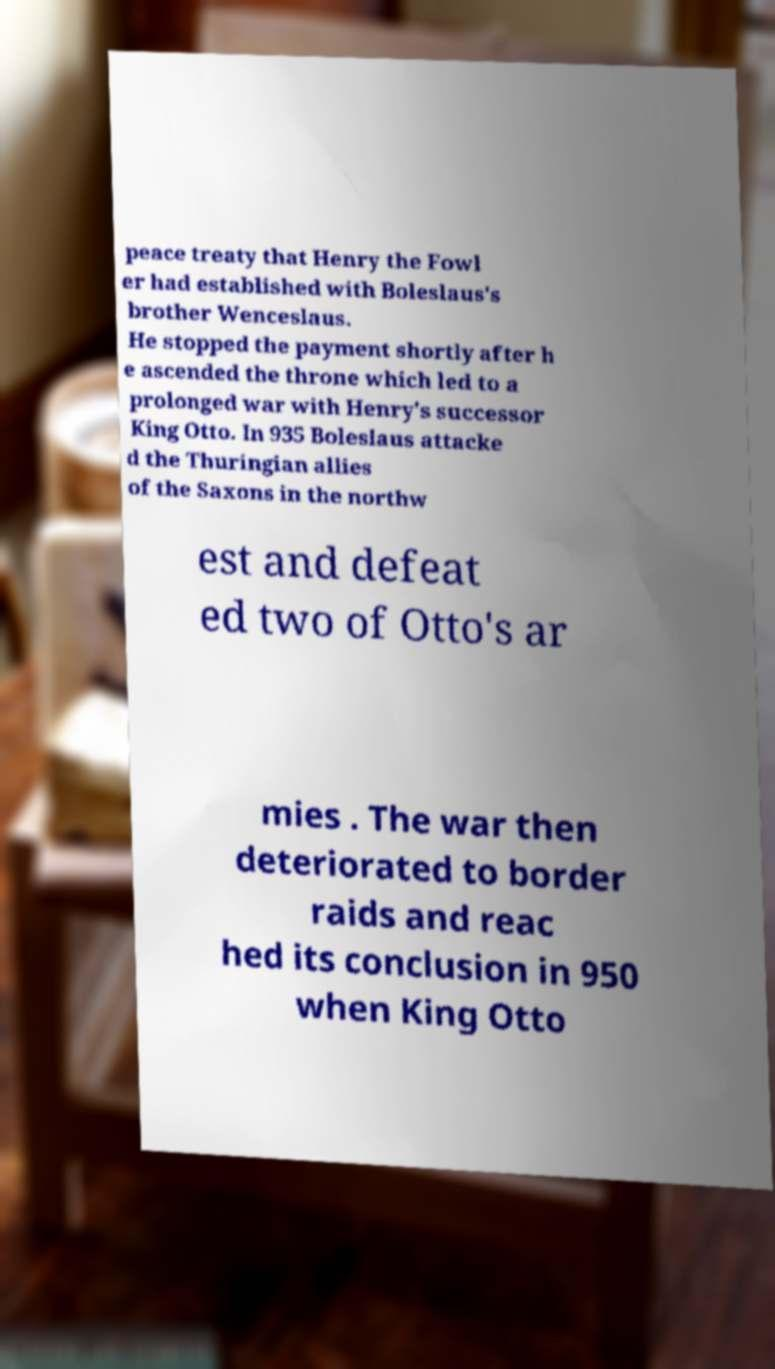Please identify and transcribe the text found in this image. peace treaty that Henry the Fowl er had established with Boleslaus's brother Wenceslaus. He stopped the payment shortly after h e ascended the throne which led to a prolonged war with Henry's successor King Otto. In 935 Boleslaus attacke d the Thuringian allies of the Saxons in the northw est and defeat ed two of Otto's ar mies . The war then deteriorated to border raids and reac hed its conclusion in 950 when King Otto 